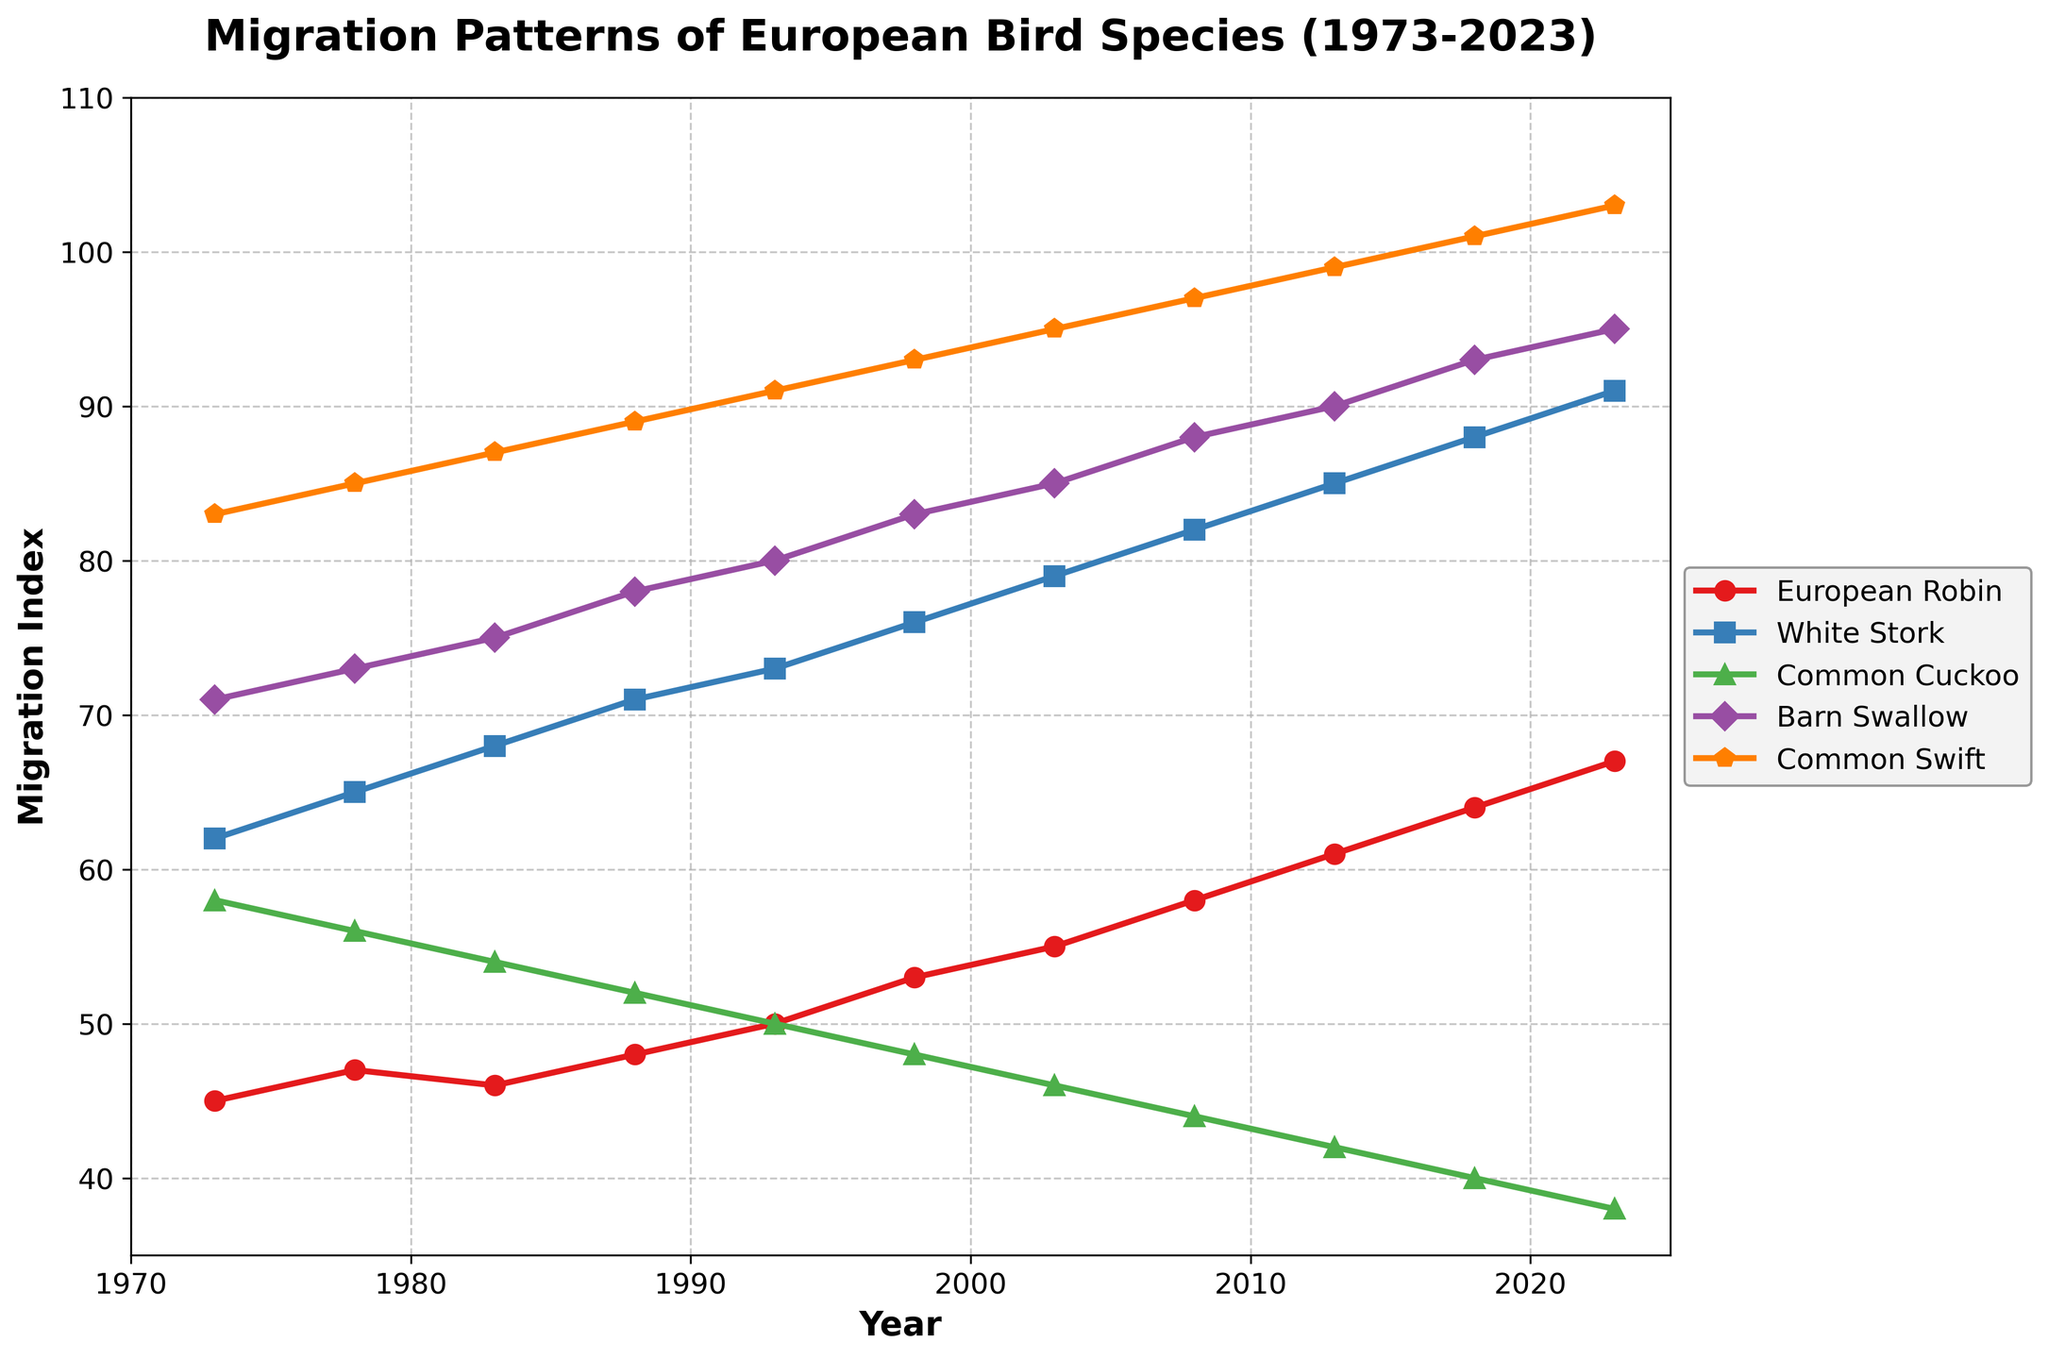Which bird species had the highest migration index in 2023? Check the values on the y-axis for the year 2023 and identify the bird species with the highest value.
Answer: Common Swift What is the average migration index of the European Robin from 1973 to 2023? Sum the migration indices of the European Robin for each year and divide by the number of years. The values are 45, 47, 46, 48, 50, 53, 55, 58, 61, 64, 67. The sum is 594, and there are 11 years. The average is 594/11.
Answer: 54 Between which two years did the Barn Swallow show the largest increase in migration index? Look through the values for the Barn Swallow across all years and identify the two consecutive years with the largest increase in values.
Answer: 1973 to 1978 Is there any year where the migration index of the Common Cuckoo and European Robin are equal? Compare the values of both species for each year and check for any year where the values match.
Answer: No Which species experienced a steady increase in migration index over the years? Identify the species that consistently show an upward trend in their migration index from 1973 to 2023.
Answer: European Robin, White Stork, Barn Swallow, Common Swift Does any bird species show a decreasing trend in migration index? Look for any species with a downward trend in the migration index from 1973 to 2023.
Answer: Common Cuckoo In which year did the migration index of the White Stork reach 85? Find the point on the graph where the White Stork's migration index is 85.
Answer: 2013 Comparing the Common Swift and the European Robin, which species had a higher migration index in 1983? Compare the values for both species in the year 1983.
Answer: Common Swift 